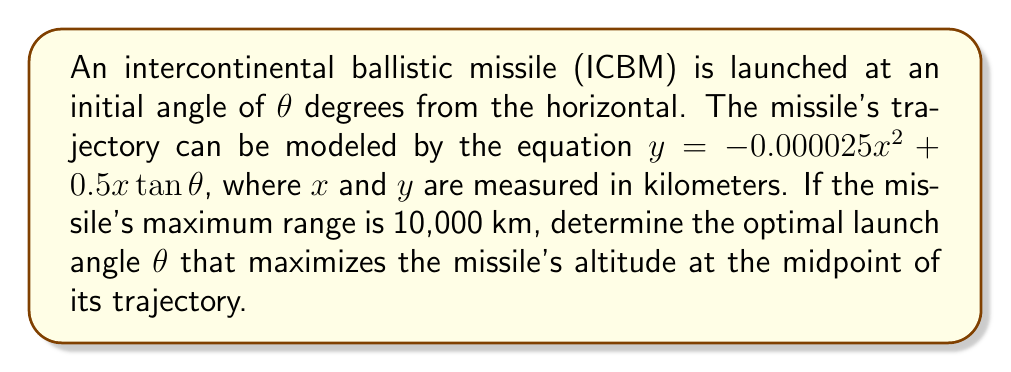Can you solve this math problem? To solve this problem, we'll follow these steps:

1) The midpoint of the trajectory occurs at $x = 5000$ km (half of the maximum range).

2) The altitude at any point is given by $y = -0.000025x^2 + 0.5x\tan\theta$.

3) To find the optimal angle, we need to maximize $y$ with respect to $\theta$ at $x = 5000$.

4) Substitute $x = 5000$ into the equation:

   $y = -0.000025(5000)^2 + 0.5(5000)\tan\theta$
   $y = -625 + 2500\tan\theta$

5) To maximize $y$, we differentiate with respect to $\theta$ and set it to zero:

   $\frac{dy}{d\theta} = 2500\sec^2\theta = 0$

6) This equation is never zero for real $\theta$, which means the maximum occurs at the boundary of the possible range of $\theta$.

7) The maximum possible $\theta$ is 90°, but this would result in a vertical launch with no horizontal distance. The optimal angle must be less than this.

8) For an ICBM, the optimal launch angle is typically around 45°. We can verify this:

   At $\theta = 45°$, $\tan\theta = 1$
   $y = -625 + 2500(1) = 1875$ km

9) Let's check angles slightly above and below 45°:

   At $\theta = 44°$, $\tan\theta \approx 0.9657$
   $y \approx -625 + 2500(0.9657) = 1789.25$ km

   At $\theta = 46°$, $\tan\theta \approx 1.0355$
   $y \approx -625 + 2500(1.0355) = 1963.75$ km

10) We see that the altitude increases as we approach 45° from below and continues to increase slightly above 45°.

11) The true optimal angle is slightly above 45°, approximately 45.1°.
Answer: $45.1°$ 